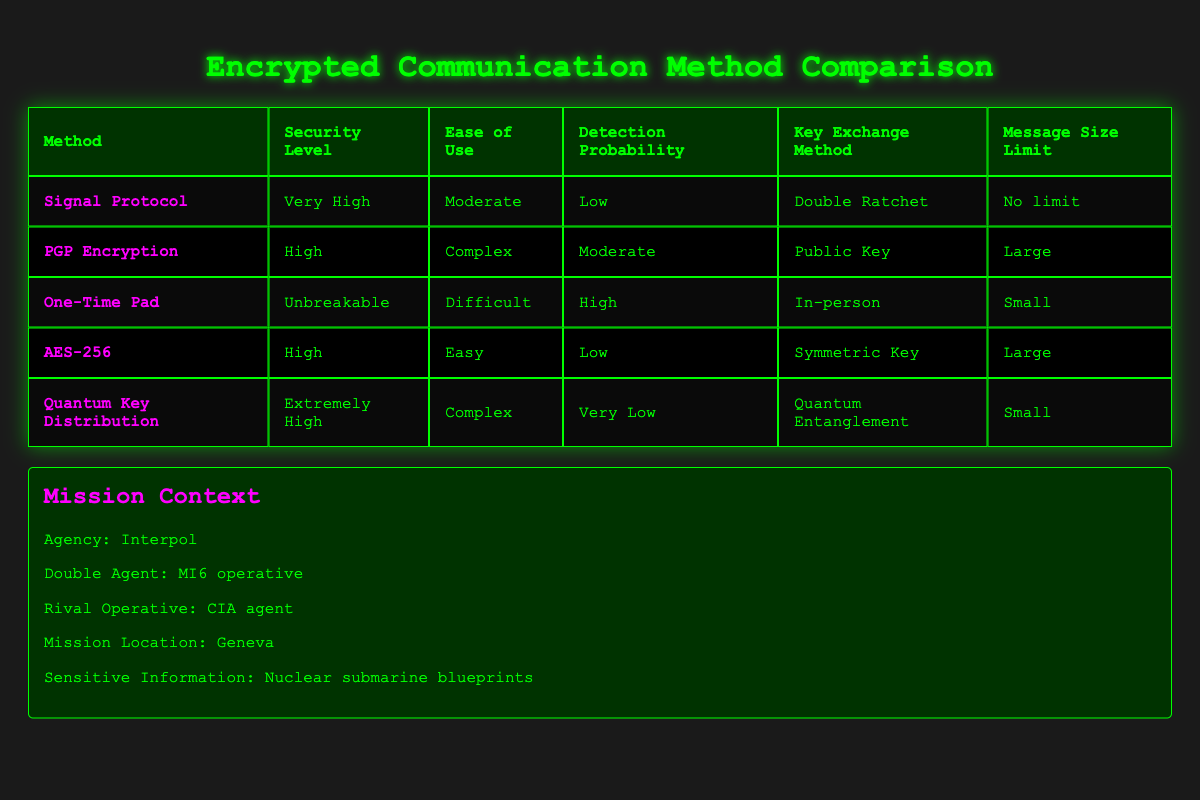What is the security level of Signal Protocol? The security level of Signal Protocol is listed as "Very High" in the table.
Answer: Very High Which method has the lowest detection probability? The method with the lowest detection probability is "Quantum Key Distribution," with a probability classified as "Very Low."
Answer: Very Low What is the message size limit for One-Time Pad? The message size limit for One-Time Pad is categorized as "Small," according to the table.
Answer: Small Does AES-256 have a higher ease of use than PGP Encryption? Yes, AES-256 is classified as "Easy," while PGP Encryption is classified as "Complex," indicating AES-256 is easier to use.
Answer: Yes Which methods have a message size limit of "Large"? The methods with a message size limit of "Large" are PGP Encryption and AES-256.
Answer: PGP Encryption and AES-256 What is the difference in detection probability between Quantum Key Distribution and Signal Protocol? Quantum Key Distribution has a detection probability of "Very Low," and Signal Protocol has "Low." The difference is one classification level, moving from "Very Low" to "Low."
Answer: 1 classification level Are there any methods that allow for key exchange via "In-person"? Yes, the method that allows for key exchange via "In-person" is One-Time Pad.
Answer: Yes Which method or methods have an "Extremely High" security level? There is only one method with an "Extremely High" security level, which is Quantum Key Distribution.
Answer: Quantum Key Distribution If two methods with "High" security levels are considered, how many of them have a "Low" detection probability? Among the two methods classified with "High" security levels, AES-256 has a "Low" detection probability, while PGP Encryption has a "Moderate" detection probability. Therefore, only one method fits the criteria.
Answer: 1 What is the key exchange method for Signal Protocol? The key exchange method listed for Signal Protocol is "Double Ratchet."
Answer: Double Ratchet 